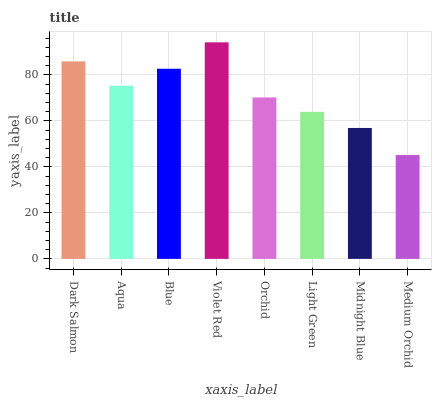Is Medium Orchid the minimum?
Answer yes or no. Yes. Is Violet Red the maximum?
Answer yes or no. Yes. Is Aqua the minimum?
Answer yes or no. No. Is Aqua the maximum?
Answer yes or no. No. Is Dark Salmon greater than Aqua?
Answer yes or no. Yes. Is Aqua less than Dark Salmon?
Answer yes or no. Yes. Is Aqua greater than Dark Salmon?
Answer yes or no. No. Is Dark Salmon less than Aqua?
Answer yes or no. No. Is Aqua the high median?
Answer yes or no. Yes. Is Orchid the low median?
Answer yes or no. Yes. Is Light Green the high median?
Answer yes or no. No. Is Medium Orchid the low median?
Answer yes or no. No. 